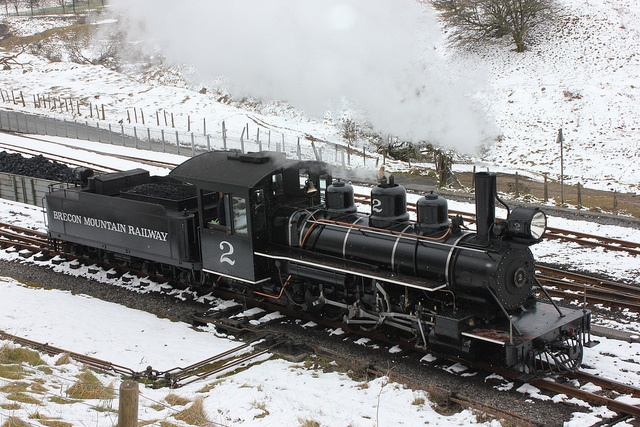Describe the objects in this image and their specific colors. I can see a train in gray, black, darkgray, and lightgray tones in this image. 